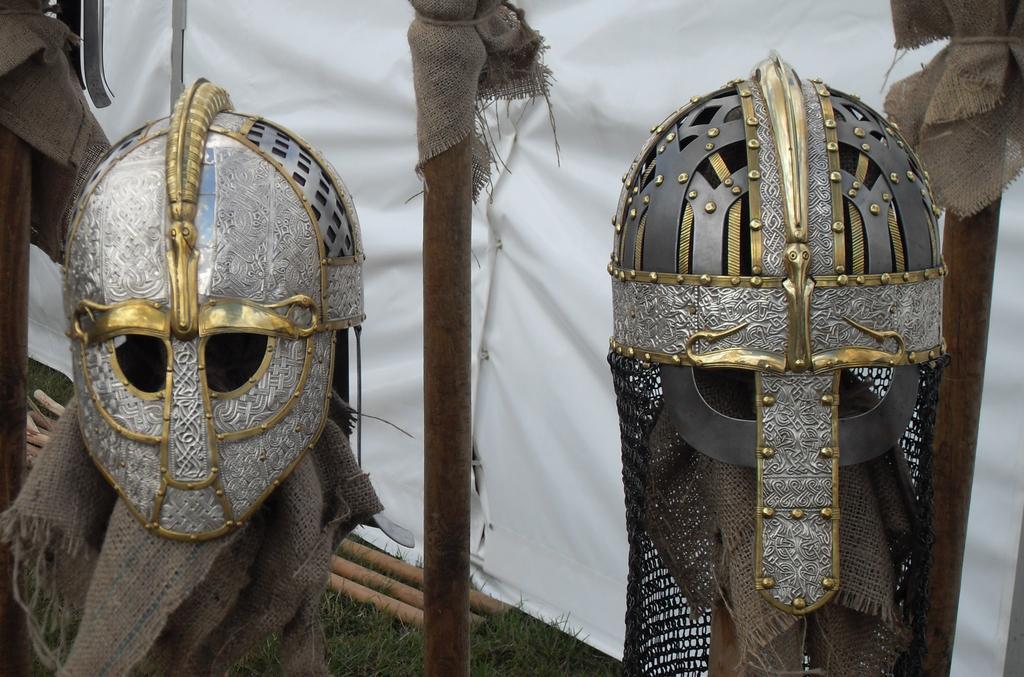How would you summarize this image in a sentence or two? As we can see in the image there is a cloth and helmets. 